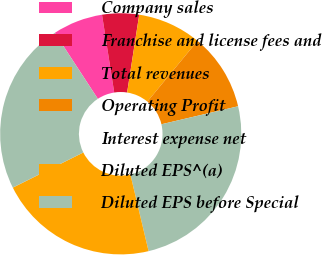<chart> <loc_0><loc_0><loc_500><loc_500><pie_chart><fcel>Company sales<fcel>Franchise and license fees and<fcel>Total revenues<fcel>Operating Profit<fcel>Interest expense net<fcel>Diluted EPS^(a)<fcel>Diluted EPS before Special<nl><fcel>6.73%<fcel>4.93%<fcel>8.54%<fcel>10.34%<fcel>24.96%<fcel>21.35%<fcel>23.15%<nl></chart> 